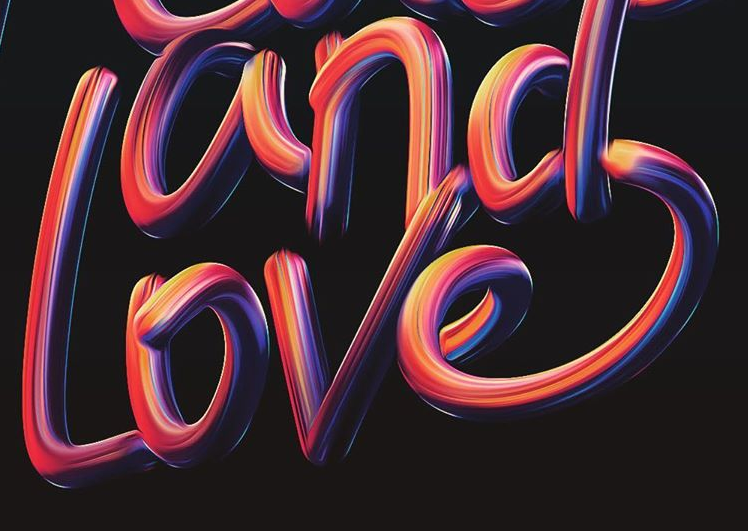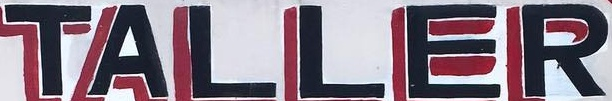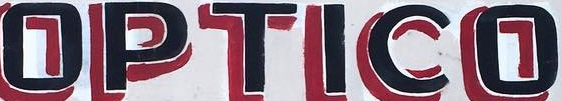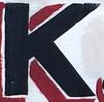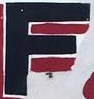What text appears in these images from left to right, separated by a semicolon? Love; TALLER; OPTICO; K; F 